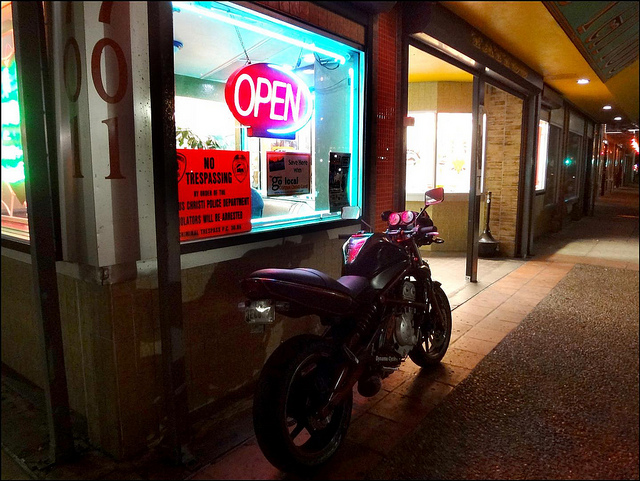Extract all visible text content from this image. 01 OPEN NO TRESPASSING ga 